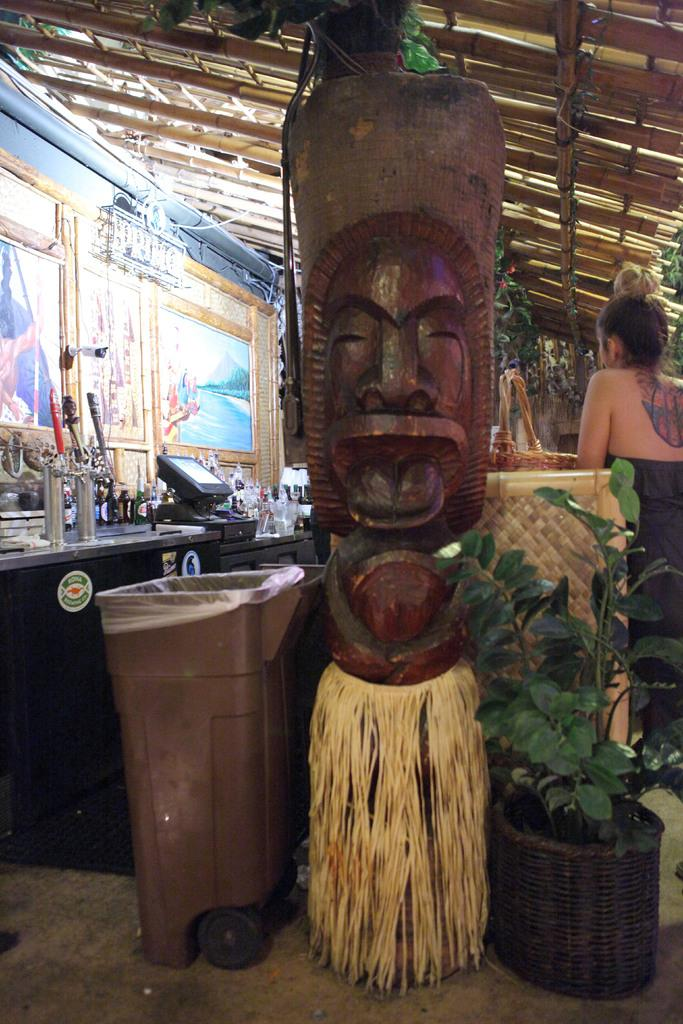What type of structure is in the foreground of the image? There is a wooden structure in the foreground of the image. Where is the dustbin located in the image? The dustbin is on the left side of the image. What type of vegetation is on the right side of the image? There is a plant on the right side of the image. What flavor of umbrella is hanging from the wooden structure in the image? There is no umbrella present in the image, and therefore no flavor can be associated with it. 